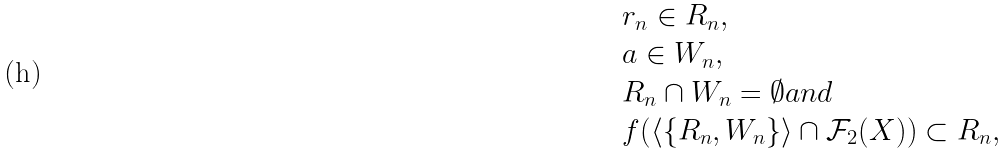<formula> <loc_0><loc_0><loc_500><loc_500>\begin{array} { l } r _ { n } \in R _ { n } , \\ a \in W _ { n } , \\ R _ { n } \cap W _ { n } = \emptyset a n d \\ f ( \langle \{ R _ { n } , W _ { n } \} \rangle \cap \mathcal { F } _ { 2 } ( X ) ) \subset R _ { n } , \end{array}</formula> 